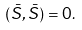Convert formula to latex. <formula><loc_0><loc_0><loc_500><loc_500>( \bar { S } , \bar { S } ) = 0 .</formula> 